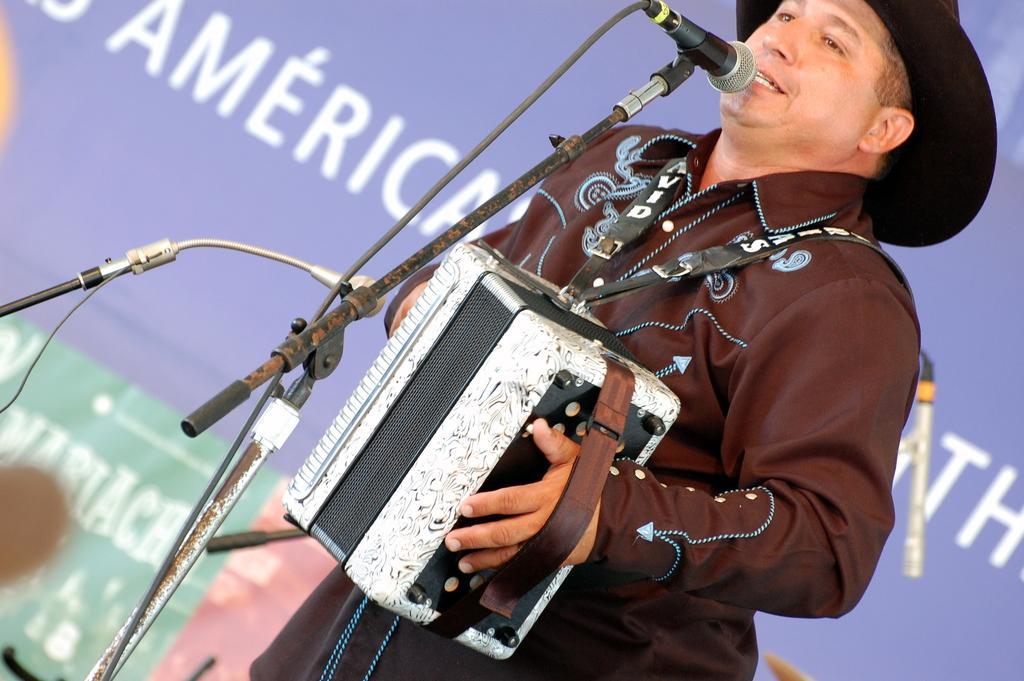Can you describe this image briefly? In this picture I can see there is a person standing and he is holding a box in his hand and he is singing, he is wearing a hat and a coat. There is a microphone in front of him and there is a microphone stand. There is a purple color banner in the background. 